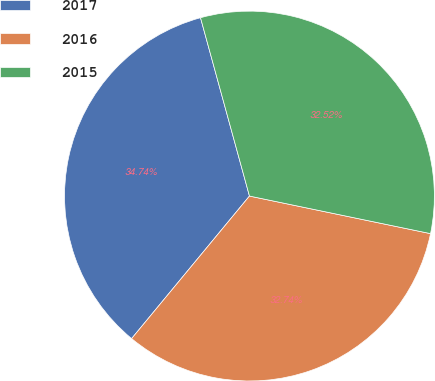Convert chart to OTSL. <chart><loc_0><loc_0><loc_500><loc_500><pie_chart><fcel>2017<fcel>2016<fcel>2015<nl><fcel>34.74%<fcel>32.74%<fcel>32.52%<nl></chart> 